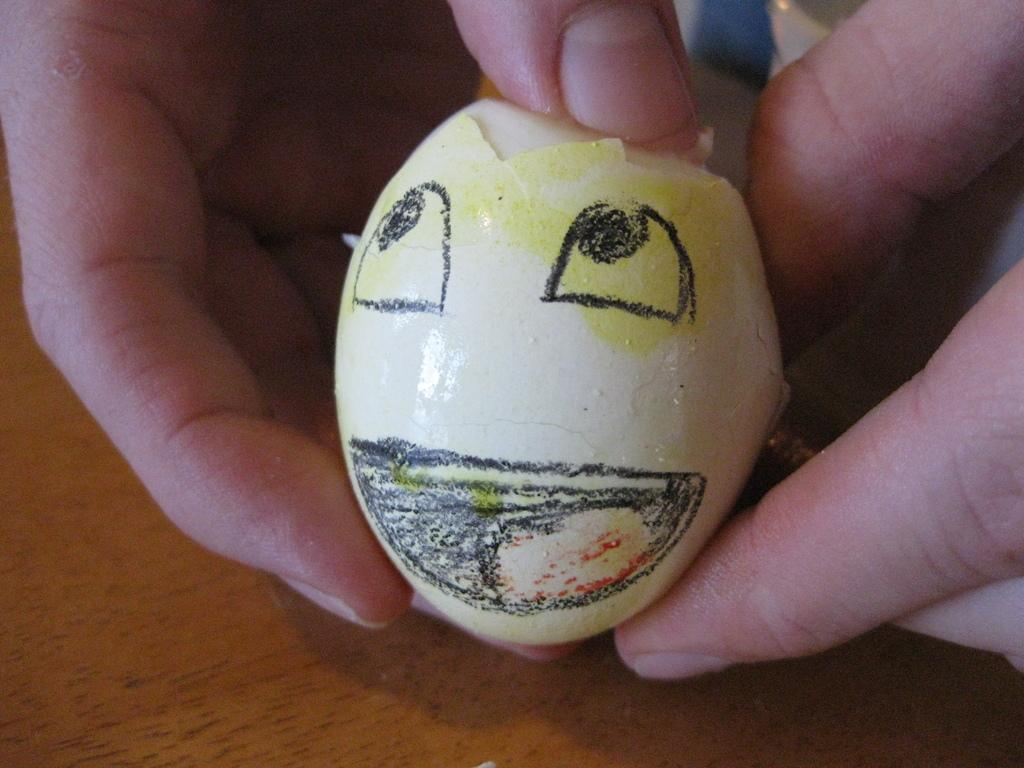What is the person's hand holding in the image? The person's hand is holding an egg in the image. What can be observed on the surface of the egg? The egg has an art on its shell. What type of surface can be seen in the image? There is a wooden surface visible in the image. Can you see the ocean in the background of the image? No, there is no ocean visible in the image. 